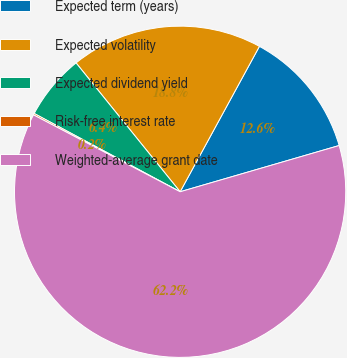<chart> <loc_0><loc_0><loc_500><loc_500><pie_chart><fcel>Expected term (years)<fcel>Expected volatility<fcel>Expected dividend yield<fcel>Risk-free interest rate<fcel>Weighted-average grant date<nl><fcel>12.55%<fcel>18.76%<fcel>6.35%<fcel>0.15%<fcel>62.19%<nl></chart> 